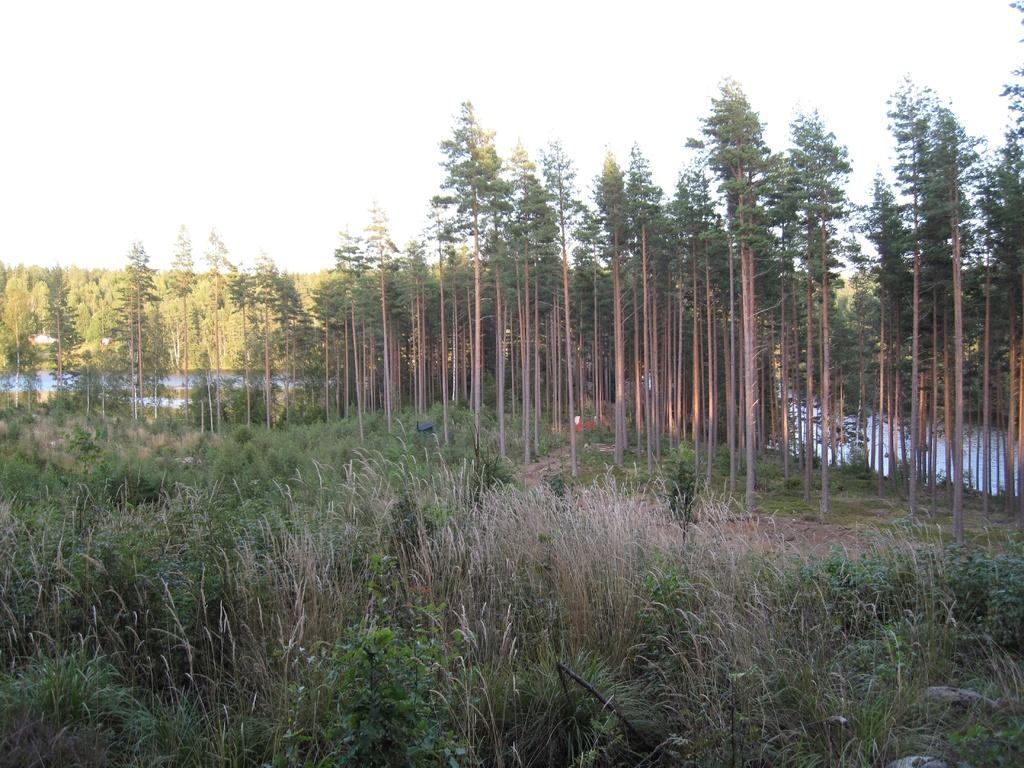What type of vegetation can be seen in the image? There is a group of trees, plants, and grass visible in the image. What natural element is present in the image besides vegetation? There is water visible in the image. What is the condition of the sky in the image? The sky is visible in the image and appears cloudy. What type of nation is depicted in the image? There is no nation depicted in the image; it features natural elements such as trees, plants, grass, water, and a cloudy sky. Can you spot a rabbit in the image? There is no rabbit present in the image. 